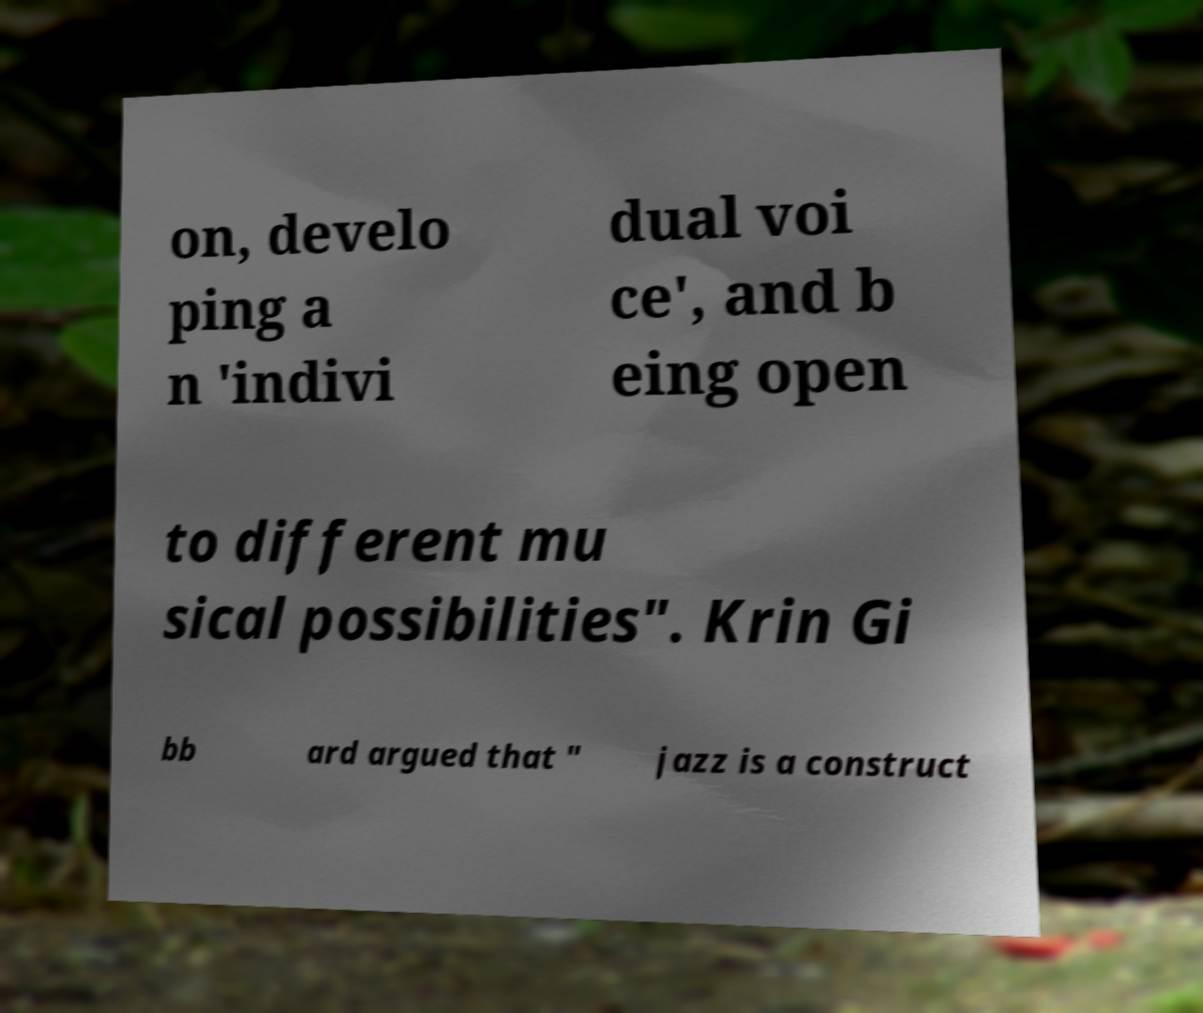Please identify and transcribe the text found in this image. on, develo ping a n 'indivi dual voi ce', and b eing open to different mu sical possibilities". Krin Gi bb ard argued that " jazz is a construct 